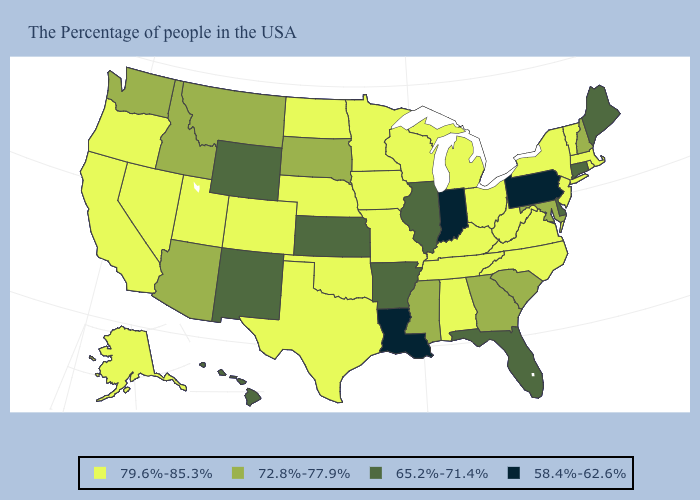How many symbols are there in the legend?
Be succinct. 4. What is the value of New Mexico?
Keep it brief. 65.2%-71.4%. How many symbols are there in the legend?
Short answer required. 4. What is the highest value in the MidWest ?
Keep it brief. 79.6%-85.3%. Name the states that have a value in the range 72.8%-77.9%?
Be succinct. New Hampshire, Maryland, South Carolina, Georgia, Mississippi, South Dakota, Montana, Arizona, Idaho, Washington. Is the legend a continuous bar?
Short answer required. No. Among the states that border Kentucky , which have the highest value?
Quick response, please. Virginia, West Virginia, Ohio, Tennessee, Missouri. Name the states that have a value in the range 72.8%-77.9%?
Write a very short answer. New Hampshire, Maryland, South Carolina, Georgia, Mississippi, South Dakota, Montana, Arizona, Idaho, Washington. Does Delaware have the same value as Idaho?
Be succinct. No. Among the states that border Georgia , which have the highest value?
Short answer required. North Carolina, Alabama, Tennessee. Among the states that border Kentucky , does Missouri have the highest value?
Concise answer only. Yes. Which states have the lowest value in the USA?
Keep it brief. Pennsylvania, Indiana, Louisiana. What is the highest value in states that border Virginia?
Answer briefly. 79.6%-85.3%. 